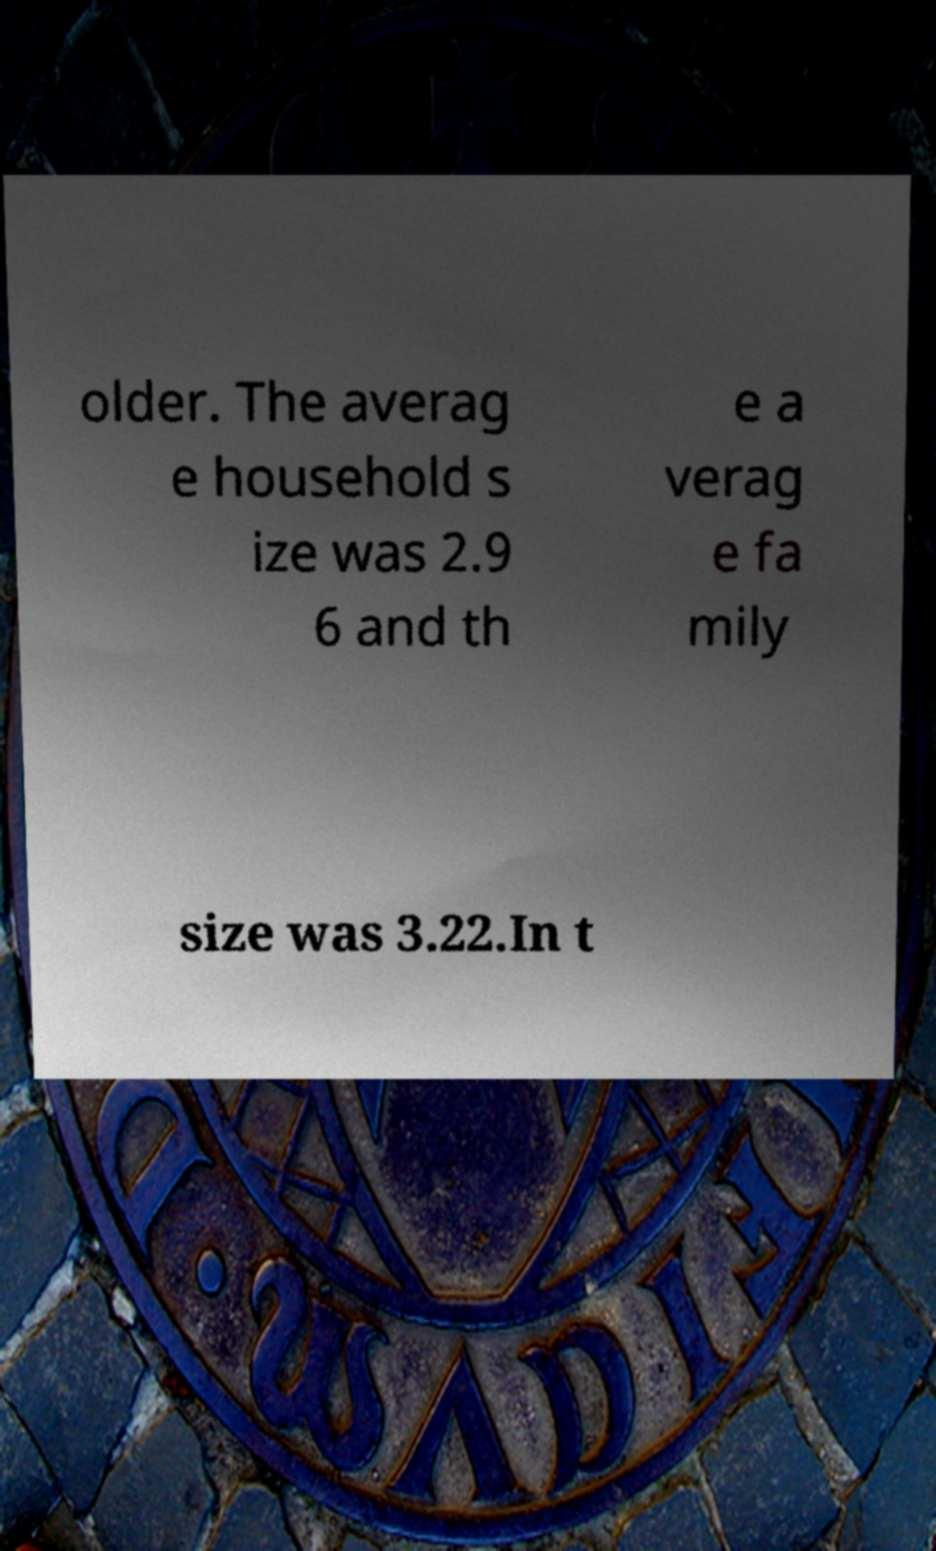Could you assist in decoding the text presented in this image and type it out clearly? older. The averag e household s ize was 2.9 6 and th e a verag e fa mily size was 3.22.In t 